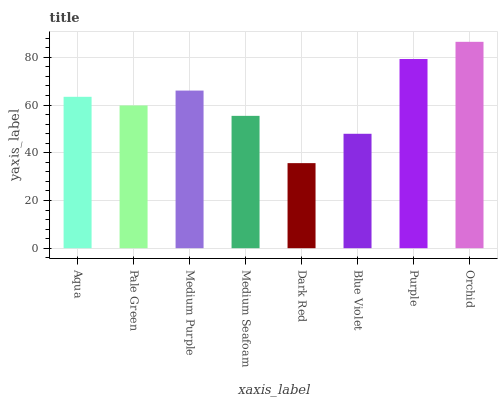Is Pale Green the minimum?
Answer yes or no. No. Is Pale Green the maximum?
Answer yes or no. No. Is Aqua greater than Pale Green?
Answer yes or no. Yes. Is Pale Green less than Aqua?
Answer yes or no. Yes. Is Pale Green greater than Aqua?
Answer yes or no. No. Is Aqua less than Pale Green?
Answer yes or no. No. Is Aqua the high median?
Answer yes or no. Yes. Is Pale Green the low median?
Answer yes or no. Yes. Is Purple the high median?
Answer yes or no. No. Is Blue Violet the low median?
Answer yes or no. No. 